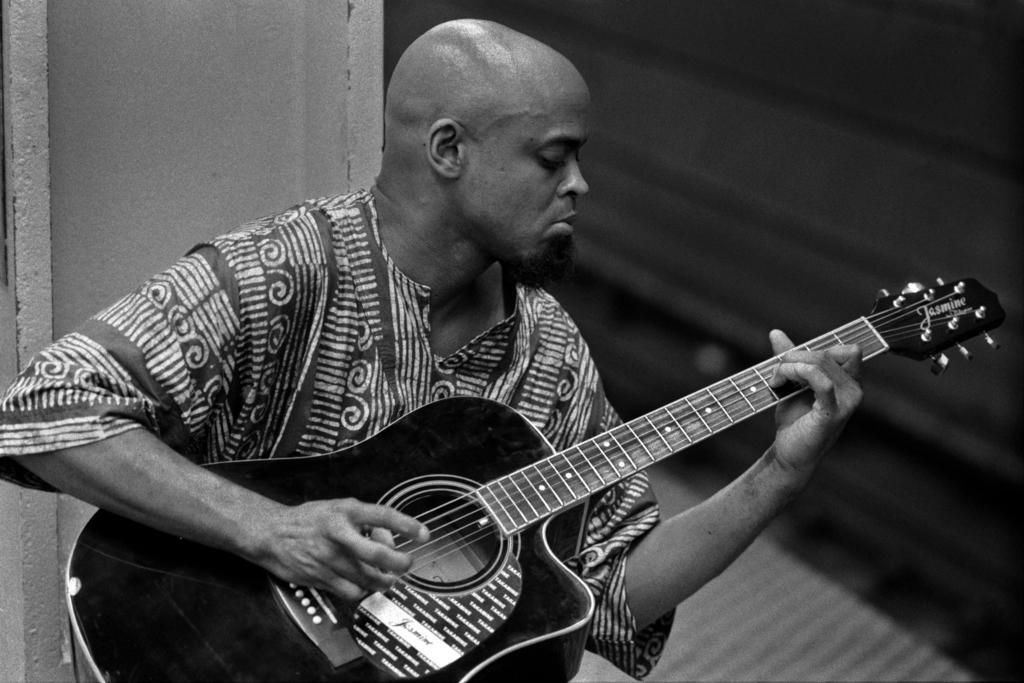How would you summarize this image in a sentence or two? a person is sitting and playing a guitar. 